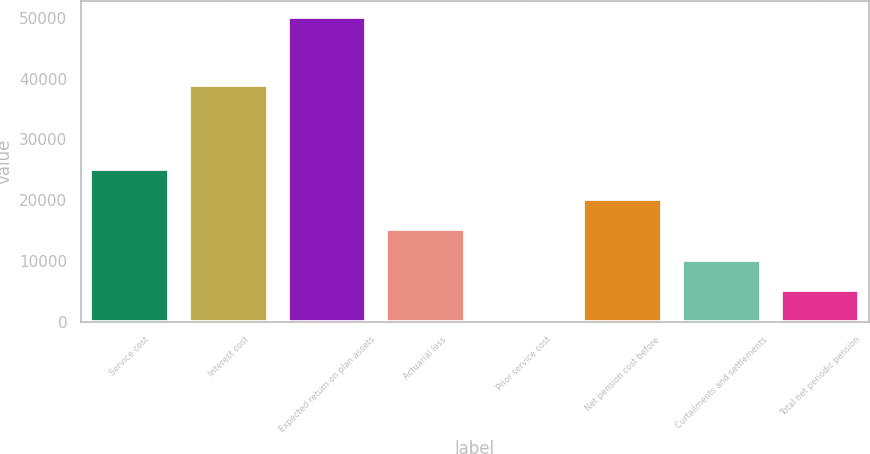Convert chart. <chart><loc_0><loc_0><loc_500><loc_500><bar_chart><fcel>Service cost<fcel>Interest cost<fcel>Expected return on plan assets<fcel>Actuarial loss<fcel>Prior service cost<fcel>Net pension cost before<fcel>Curtailments and settlements<fcel>Total net periodic pension<nl><fcel>25225<fcel>38892<fcel>50190<fcel>15239<fcel>260<fcel>20232<fcel>10246<fcel>5253<nl></chart> 